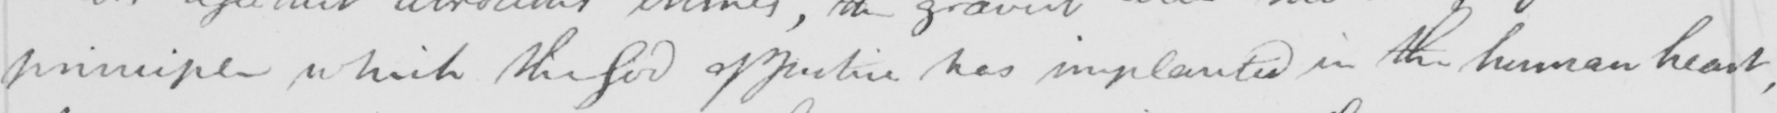Transcribe the text shown in this historical manuscript line. principle which the God of Justice has implanted in the human heart , 